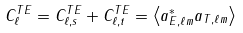<formula> <loc_0><loc_0><loc_500><loc_500>C _ { \ell } ^ { T E } = C _ { \ell , s } ^ { T E } + C _ { \ell , t } ^ { T E } = \left \langle a _ { E , \ell m } ^ { * } a _ { T , \ell m } \right \rangle</formula> 